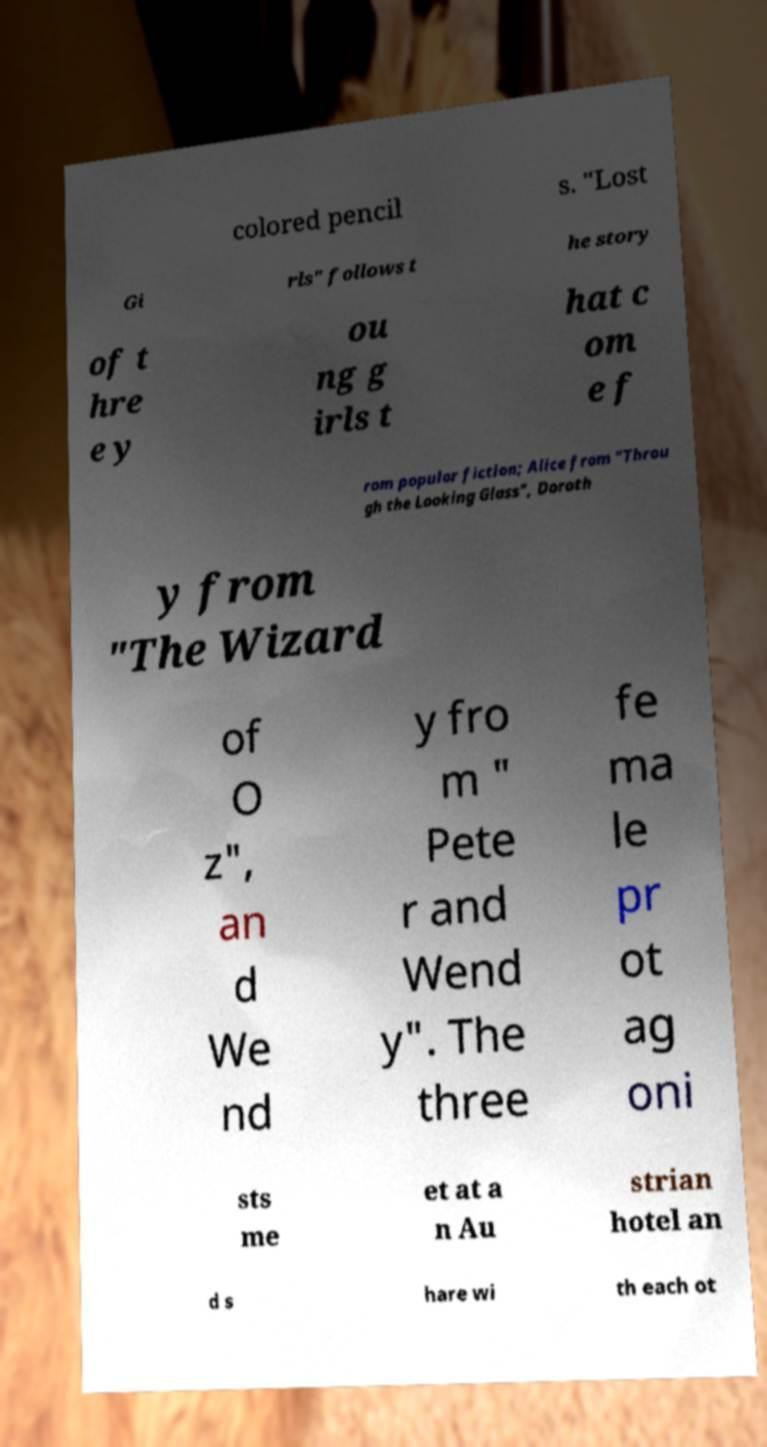What messages or text are displayed in this image? I need them in a readable, typed format. colored pencil s. "Lost Gi rls" follows t he story of t hre e y ou ng g irls t hat c om e f rom popular fiction; Alice from "Throu gh the Looking Glass", Doroth y from "The Wizard of O z", an d We nd y fro m " Pete r and Wend y". The three fe ma le pr ot ag oni sts me et at a n Au strian hotel an d s hare wi th each ot 